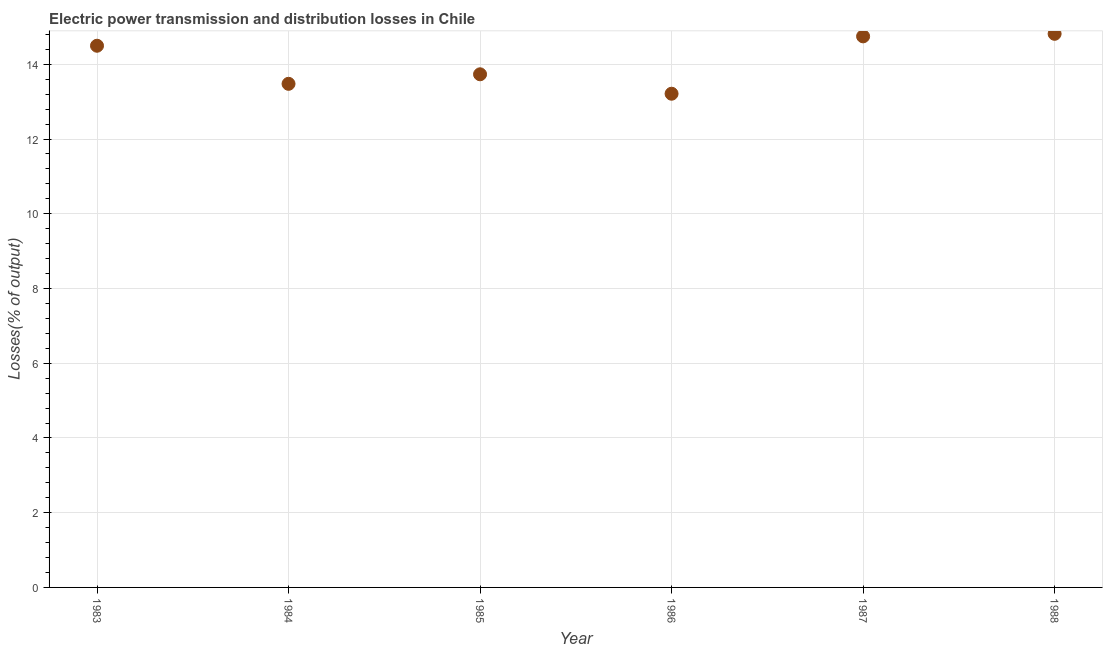What is the electric power transmission and distribution losses in 1988?
Your answer should be very brief. 14.82. Across all years, what is the maximum electric power transmission and distribution losses?
Your answer should be very brief. 14.82. Across all years, what is the minimum electric power transmission and distribution losses?
Your response must be concise. 13.21. In which year was the electric power transmission and distribution losses minimum?
Provide a short and direct response. 1986. What is the sum of the electric power transmission and distribution losses?
Ensure brevity in your answer.  84.48. What is the difference between the electric power transmission and distribution losses in 1983 and 1984?
Your response must be concise. 1.02. What is the average electric power transmission and distribution losses per year?
Make the answer very short. 14.08. What is the median electric power transmission and distribution losses?
Give a very brief answer. 14.11. In how many years, is the electric power transmission and distribution losses greater than 10 %?
Provide a succinct answer. 6. Do a majority of the years between 1984 and 1988 (inclusive) have electric power transmission and distribution losses greater than 2.8 %?
Offer a terse response. Yes. What is the ratio of the electric power transmission and distribution losses in 1984 to that in 1986?
Make the answer very short. 1.02. Is the electric power transmission and distribution losses in 1984 less than that in 1986?
Provide a short and direct response. No. Is the difference between the electric power transmission and distribution losses in 1985 and 1986 greater than the difference between any two years?
Your answer should be very brief. No. What is the difference between the highest and the second highest electric power transmission and distribution losses?
Offer a very short reply. 0.07. What is the difference between the highest and the lowest electric power transmission and distribution losses?
Provide a short and direct response. 1.6. What is the difference between two consecutive major ticks on the Y-axis?
Ensure brevity in your answer.  2. Does the graph contain any zero values?
Keep it short and to the point. No. Does the graph contain grids?
Give a very brief answer. Yes. What is the title of the graph?
Your answer should be very brief. Electric power transmission and distribution losses in Chile. What is the label or title of the X-axis?
Keep it short and to the point. Year. What is the label or title of the Y-axis?
Your answer should be very brief. Losses(% of output). What is the Losses(% of output) in 1983?
Provide a succinct answer. 14.5. What is the Losses(% of output) in 1984?
Your answer should be very brief. 13.48. What is the Losses(% of output) in 1985?
Offer a very short reply. 13.73. What is the Losses(% of output) in 1986?
Offer a terse response. 13.21. What is the Losses(% of output) in 1987?
Provide a short and direct response. 14.75. What is the Losses(% of output) in 1988?
Your answer should be very brief. 14.82. What is the difference between the Losses(% of output) in 1983 and 1984?
Ensure brevity in your answer.  1.02. What is the difference between the Losses(% of output) in 1983 and 1985?
Your response must be concise. 0.76. What is the difference between the Losses(% of output) in 1983 and 1986?
Ensure brevity in your answer.  1.28. What is the difference between the Losses(% of output) in 1983 and 1987?
Keep it short and to the point. -0.25. What is the difference between the Losses(% of output) in 1983 and 1988?
Your response must be concise. -0.32. What is the difference between the Losses(% of output) in 1984 and 1985?
Your answer should be very brief. -0.26. What is the difference between the Losses(% of output) in 1984 and 1986?
Offer a terse response. 0.26. What is the difference between the Losses(% of output) in 1984 and 1987?
Your response must be concise. -1.27. What is the difference between the Losses(% of output) in 1984 and 1988?
Offer a terse response. -1.34. What is the difference between the Losses(% of output) in 1985 and 1986?
Offer a terse response. 0.52. What is the difference between the Losses(% of output) in 1985 and 1987?
Give a very brief answer. -1.01. What is the difference between the Losses(% of output) in 1985 and 1988?
Give a very brief answer. -1.08. What is the difference between the Losses(% of output) in 1986 and 1987?
Your answer should be compact. -1.53. What is the difference between the Losses(% of output) in 1986 and 1988?
Make the answer very short. -1.6. What is the difference between the Losses(% of output) in 1987 and 1988?
Your answer should be compact. -0.07. What is the ratio of the Losses(% of output) in 1983 to that in 1984?
Ensure brevity in your answer.  1.08. What is the ratio of the Losses(% of output) in 1983 to that in 1985?
Provide a succinct answer. 1.06. What is the ratio of the Losses(% of output) in 1983 to that in 1986?
Give a very brief answer. 1.1. What is the ratio of the Losses(% of output) in 1984 to that in 1985?
Ensure brevity in your answer.  0.98. What is the ratio of the Losses(% of output) in 1984 to that in 1987?
Provide a succinct answer. 0.91. What is the ratio of the Losses(% of output) in 1984 to that in 1988?
Ensure brevity in your answer.  0.91. What is the ratio of the Losses(% of output) in 1985 to that in 1986?
Make the answer very short. 1.04. What is the ratio of the Losses(% of output) in 1985 to that in 1988?
Your answer should be compact. 0.93. What is the ratio of the Losses(% of output) in 1986 to that in 1987?
Provide a short and direct response. 0.9. What is the ratio of the Losses(% of output) in 1986 to that in 1988?
Offer a terse response. 0.89. What is the ratio of the Losses(% of output) in 1987 to that in 1988?
Offer a very short reply. 0.99. 